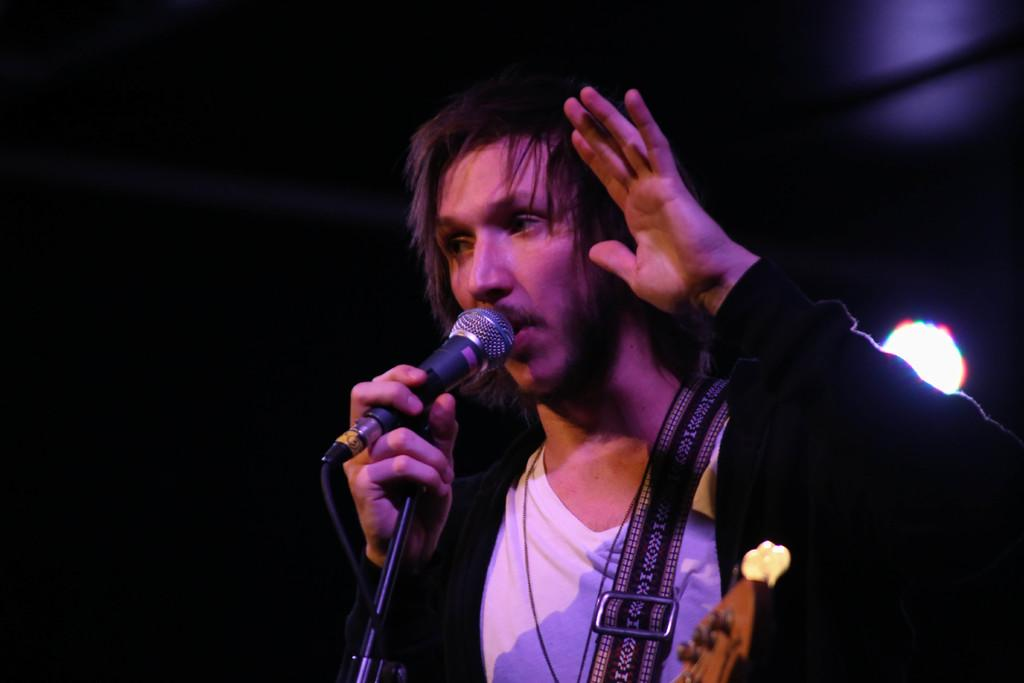Who is the main subject in the image? There is a man in the center of the image. What is the man holding in the image? The man is holding a microphone. What type of space-related item can be seen in the image? There is no space-related item present in the image. Can you tell me how much the man paid for the microphone based on the receipt in the image? There is no receipt present in the image. 